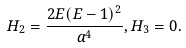<formula> <loc_0><loc_0><loc_500><loc_500>H _ { 2 } = \frac { 2 E ( E - 1 ) ^ { 2 } } { a ^ { 4 } } , H _ { 3 } = 0 .</formula> 